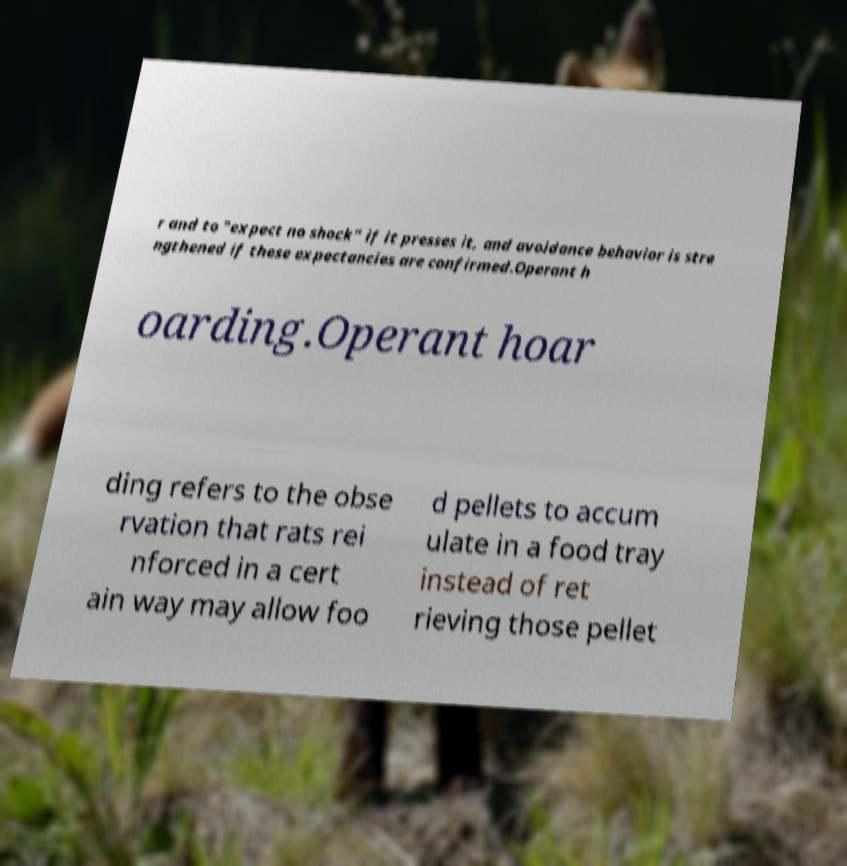Could you assist in decoding the text presented in this image and type it out clearly? r and to "expect no shock" if it presses it, and avoidance behavior is stre ngthened if these expectancies are confirmed.Operant h oarding.Operant hoar ding refers to the obse rvation that rats rei nforced in a cert ain way may allow foo d pellets to accum ulate in a food tray instead of ret rieving those pellet 